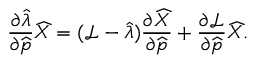Convert formula to latex. <formula><loc_0><loc_0><loc_500><loc_500>\frac { \partial \widehat { \lambda } } { \partial \widehat { p } } \widehat { X } = ( \mathcal { L } - \widehat { \lambda } ) \frac { \partial \widehat { X } } { \partial \widehat { p } } + \frac { \partial \mathcal { L } } { \partial \widehat { p } } \widehat { X } .</formula> 